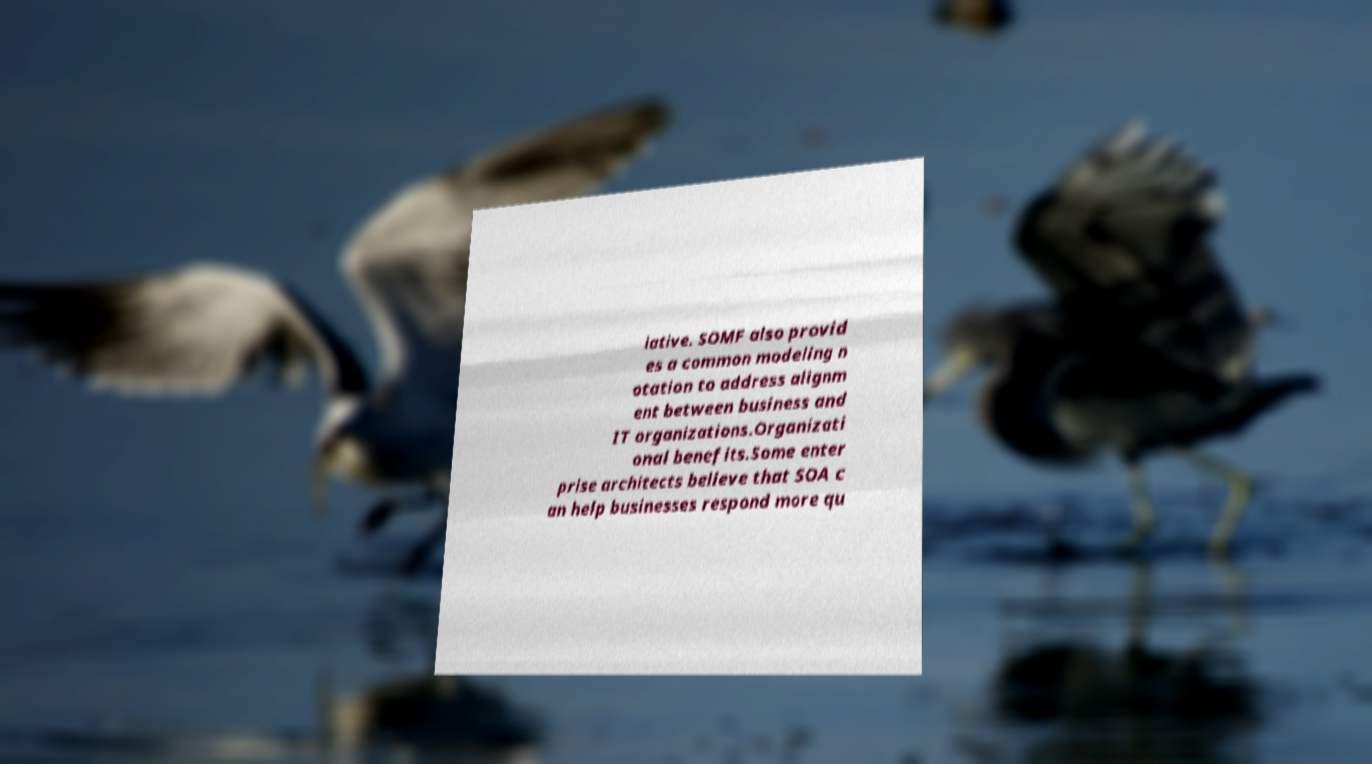Can you read and provide the text displayed in the image?This photo seems to have some interesting text. Can you extract and type it out for me? iative. SOMF also provid es a common modeling n otation to address alignm ent between business and IT organizations.Organizati onal benefits.Some enter prise architects believe that SOA c an help businesses respond more qu 